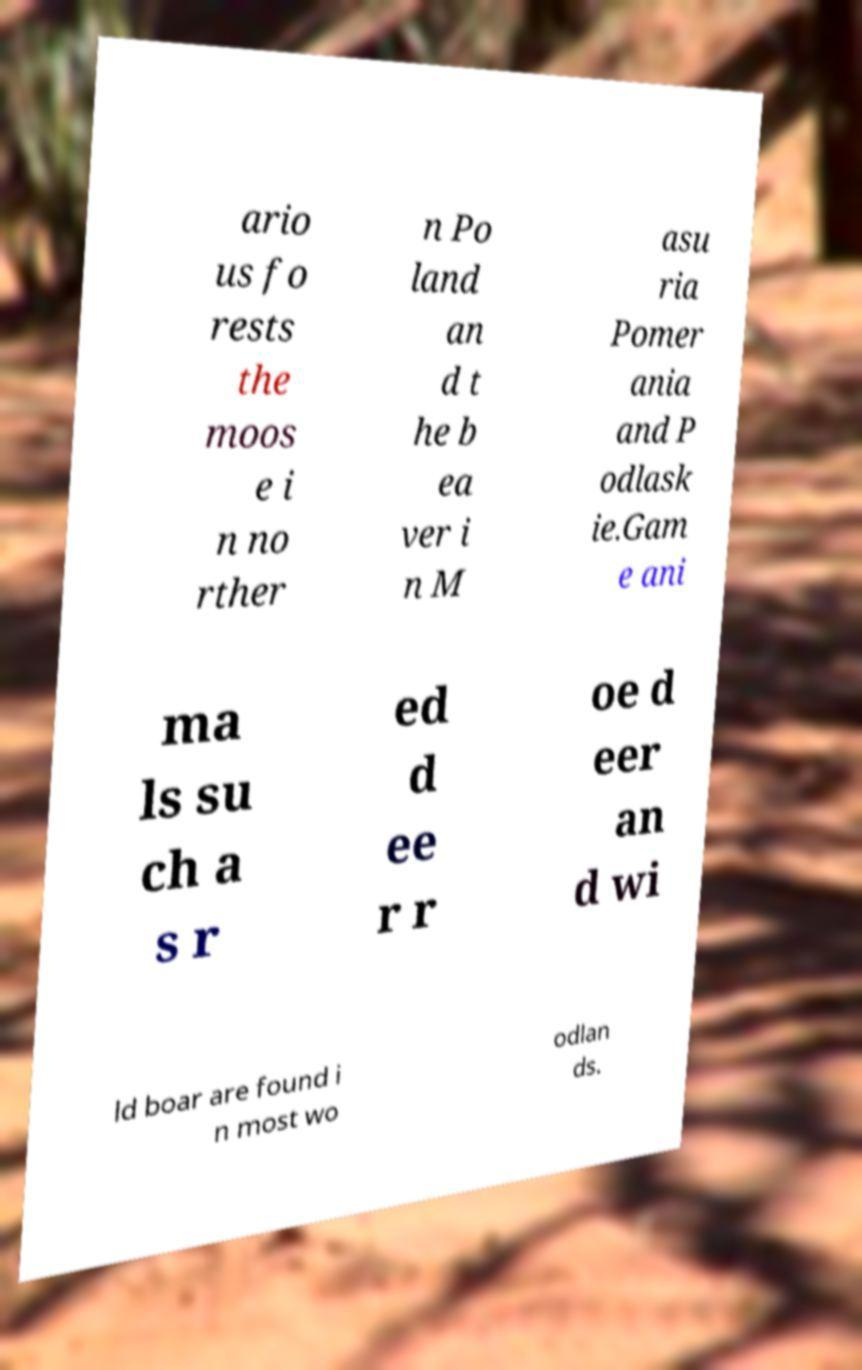Please read and relay the text visible in this image. What does it say? ario us fo rests the moos e i n no rther n Po land an d t he b ea ver i n M asu ria Pomer ania and P odlask ie.Gam e ani ma ls su ch a s r ed d ee r r oe d eer an d wi ld boar are found i n most wo odlan ds. 